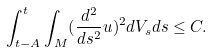Convert formula to latex. <formula><loc_0><loc_0><loc_500><loc_500>\int _ { t - A } ^ { t } \int _ { M } ( \frac { d ^ { 2 } } { d s ^ { 2 } } u ) ^ { 2 } d V _ { s } d s \leq C .</formula> 